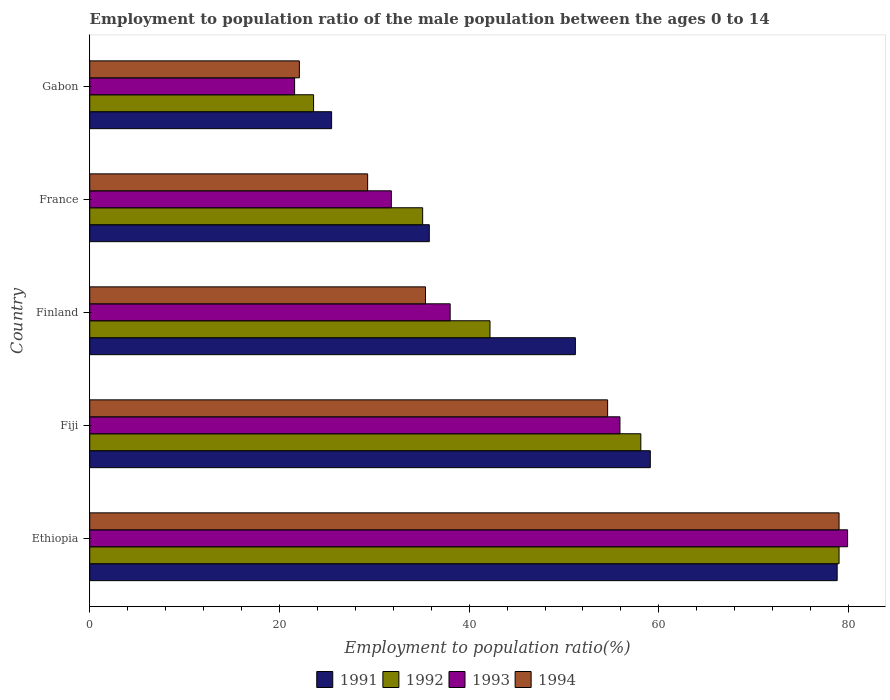How many different coloured bars are there?
Ensure brevity in your answer.  4. How many groups of bars are there?
Provide a succinct answer. 5. Are the number of bars per tick equal to the number of legend labels?
Your answer should be compact. Yes. Are the number of bars on each tick of the Y-axis equal?
Offer a very short reply. Yes. How many bars are there on the 3rd tick from the top?
Offer a very short reply. 4. What is the label of the 2nd group of bars from the top?
Your answer should be compact. France. What is the employment to population ratio in 1994 in France?
Offer a very short reply. 29.3. Across all countries, what is the maximum employment to population ratio in 1992?
Your answer should be compact. 79. In which country was the employment to population ratio in 1992 maximum?
Keep it short and to the point. Ethiopia. In which country was the employment to population ratio in 1991 minimum?
Offer a terse response. Gabon. What is the total employment to population ratio in 1992 in the graph?
Offer a terse response. 238. What is the difference between the employment to population ratio in 1991 in Ethiopia and that in Fiji?
Keep it short and to the point. 19.7. What is the difference between the employment to population ratio in 1993 in France and the employment to population ratio in 1994 in Ethiopia?
Your answer should be very brief. -47.2. What is the average employment to population ratio in 1991 per country?
Make the answer very short. 50.08. What is the difference between the employment to population ratio in 1991 and employment to population ratio in 1992 in Gabon?
Keep it short and to the point. 1.9. In how many countries, is the employment to population ratio in 1992 greater than 64 %?
Make the answer very short. 1. What is the ratio of the employment to population ratio in 1994 in Fiji to that in France?
Give a very brief answer. 1.86. Is the difference between the employment to population ratio in 1991 in Fiji and France greater than the difference between the employment to population ratio in 1992 in Fiji and France?
Keep it short and to the point. Yes. What is the difference between the highest and the second highest employment to population ratio in 1993?
Ensure brevity in your answer.  24. What is the difference between the highest and the lowest employment to population ratio in 1992?
Provide a short and direct response. 55.4. Is the sum of the employment to population ratio in 1994 in Fiji and Finland greater than the maximum employment to population ratio in 1991 across all countries?
Make the answer very short. Yes. Is it the case that in every country, the sum of the employment to population ratio in 1993 and employment to population ratio in 1991 is greater than the sum of employment to population ratio in 1992 and employment to population ratio in 1994?
Offer a very short reply. No. What does the 1st bar from the bottom in France represents?
Make the answer very short. 1991. Is it the case that in every country, the sum of the employment to population ratio in 1994 and employment to population ratio in 1993 is greater than the employment to population ratio in 1992?
Your response must be concise. Yes. How many bars are there?
Keep it short and to the point. 20. How many countries are there in the graph?
Your answer should be very brief. 5. What is the difference between two consecutive major ticks on the X-axis?
Provide a short and direct response. 20. Does the graph contain any zero values?
Provide a short and direct response. No. Where does the legend appear in the graph?
Your answer should be compact. Bottom center. How many legend labels are there?
Give a very brief answer. 4. How are the legend labels stacked?
Make the answer very short. Horizontal. What is the title of the graph?
Offer a terse response. Employment to population ratio of the male population between the ages 0 to 14. Does "1966" appear as one of the legend labels in the graph?
Your response must be concise. No. What is the Employment to population ratio(%) in 1991 in Ethiopia?
Keep it short and to the point. 78.8. What is the Employment to population ratio(%) of 1992 in Ethiopia?
Your answer should be very brief. 79. What is the Employment to population ratio(%) in 1993 in Ethiopia?
Provide a succinct answer. 79.9. What is the Employment to population ratio(%) in 1994 in Ethiopia?
Your answer should be compact. 79. What is the Employment to population ratio(%) in 1991 in Fiji?
Your answer should be compact. 59.1. What is the Employment to population ratio(%) of 1992 in Fiji?
Keep it short and to the point. 58.1. What is the Employment to population ratio(%) in 1993 in Fiji?
Make the answer very short. 55.9. What is the Employment to population ratio(%) in 1994 in Fiji?
Provide a short and direct response. 54.6. What is the Employment to population ratio(%) in 1991 in Finland?
Give a very brief answer. 51.2. What is the Employment to population ratio(%) in 1992 in Finland?
Ensure brevity in your answer.  42.2. What is the Employment to population ratio(%) of 1993 in Finland?
Give a very brief answer. 38. What is the Employment to population ratio(%) of 1994 in Finland?
Ensure brevity in your answer.  35.4. What is the Employment to population ratio(%) in 1991 in France?
Keep it short and to the point. 35.8. What is the Employment to population ratio(%) of 1992 in France?
Your answer should be very brief. 35.1. What is the Employment to population ratio(%) in 1993 in France?
Give a very brief answer. 31.8. What is the Employment to population ratio(%) of 1994 in France?
Your answer should be compact. 29.3. What is the Employment to population ratio(%) in 1992 in Gabon?
Keep it short and to the point. 23.6. What is the Employment to population ratio(%) in 1993 in Gabon?
Offer a very short reply. 21.6. What is the Employment to population ratio(%) in 1994 in Gabon?
Your response must be concise. 22.1. Across all countries, what is the maximum Employment to population ratio(%) of 1991?
Provide a short and direct response. 78.8. Across all countries, what is the maximum Employment to population ratio(%) in 1992?
Provide a succinct answer. 79. Across all countries, what is the maximum Employment to population ratio(%) of 1993?
Offer a terse response. 79.9. Across all countries, what is the maximum Employment to population ratio(%) in 1994?
Provide a succinct answer. 79. Across all countries, what is the minimum Employment to population ratio(%) of 1991?
Your answer should be very brief. 25.5. Across all countries, what is the minimum Employment to population ratio(%) of 1992?
Make the answer very short. 23.6. Across all countries, what is the minimum Employment to population ratio(%) in 1993?
Your answer should be compact. 21.6. Across all countries, what is the minimum Employment to population ratio(%) of 1994?
Provide a short and direct response. 22.1. What is the total Employment to population ratio(%) in 1991 in the graph?
Offer a very short reply. 250.4. What is the total Employment to population ratio(%) of 1992 in the graph?
Provide a short and direct response. 238. What is the total Employment to population ratio(%) in 1993 in the graph?
Provide a succinct answer. 227.2. What is the total Employment to population ratio(%) in 1994 in the graph?
Give a very brief answer. 220.4. What is the difference between the Employment to population ratio(%) in 1991 in Ethiopia and that in Fiji?
Make the answer very short. 19.7. What is the difference between the Employment to population ratio(%) in 1992 in Ethiopia and that in Fiji?
Make the answer very short. 20.9. What is the difference between the Employment to population ratio(%) of 1993 in Ethiopia and that in Fiji?
Make the answer very short. 24. What is the difference between the Employment to population ratio(%) in 1994 in Ethiopia and that in Fiji?
Offer a very short reply. 24.4. What is the difference between the Employment to population ratio(%) in 1991 in Ethiopia and that in Finland?
Offer a very short reply. 27.6. What is the difference between the Employment to population ratio(%) of 1992 in Ethiopia and that in Finland?
Offer a terse response. 36.8. What is the difference between the Employment to population ratio(%) in 1993 in Ethiopia and that in Finland?
Your response must be concise. 41.9. What is the difference between the Employment to population ratio(%) in 1994 in Ethiopia and that in Finland?
Your answer should be very brief. 43.6. What is the difference between the Employment to population ratio(%) of 1992 in Ethiopia and that in France?
Offer a very short reply. 43.9. What is the difference between the Employment to population ratio(%) in 1993 in Ethiopia and that in France?
Provide a succinct answer. 48.1. What is the difference between the Employment to population ratio(%) in 1994 in Ethiopia and that in France?
Offer a terse response. 49.7. What is the difference between the Employment to population ratio(%) in 1991 in Ethiopia and that in Gabon?
Your response must be concise. 53.3. What is the difference between the Employment to population ratio(%) in 1992 in Ethiopia and that in Gabon?
Offer a very short reply. 55.4. What is the difference between the Employment to population ratio(%) in 1993 in Ethiopia and that in Gabon?
Your response must be concise. 58.3. What is the difference between the Employment to population ratio(%) in 1994 in Ethiopia and that in Gabon?
Give a very brief answer. 56.9. What is the difference between the Employment to population ratio(%) in 1991 in Fiji and that in Finland?
Provide a short and direct response. 7.9. What is the difference between the Employment to population ratio(%) in 1993 in Fiji and that in Finland?
Offer a very short reply. 17.9. What is the difference between the Employment to population ratio(%) in 1991 in Fiji and that in France?
Your answer should be very brief. 23.3. What is the difference between the Employment to population ratio(%) in 1993 in Fiji and that in France?
Your answer should be compact. 24.1. What is the difference between the Employment to population ratio(%) of 1994 in Fiji and that in France?
Keep it short and to the point. 25.3. What is the difference between the Employment to population ratio(%) in 1991 in Fiji and that in Gabon?
Ensure brevity in your answer.  33.6. What is the difference between the Employment to population ratio(%) of 1992 in Fiji and that in Gabon?
Offer a terse response. 34.5. What is the difference between the Employment to population ratio(%) of 1993 in Fiji and that in Gabon?
Your response must be concise. 34.3. What is the difference between the Employment to population ratio(%) in 1994 in Fiji and that in Gabon?
Give a very brief answer. 32.5. What is the difference between the Employment to population ratio(%) in 1991 in Finland and that in France?
Your answer should be very brief. 15.4. What is the difference between the Employment to population ratio(%) in 1993 in Finland and that in France?
Your response must be concise. 6.2. What is the difference between the Employment to population ratio(%) in 1994 in Finland and that in France?
Provide a succinct answer. 6.1. What is the difference between the Employment to population ratio(%) of 1991 in Finland and that in Gabon?
Keep it short and to the point. 25.7. What is the difference between the Employment to population ratio(%) of 1993 in Finland and that in Gabon?
Your answer should be compact. 16.4. What is the difference between the Employment to population ratio(%) of 1994 in Finland and that in Gabon?
Give a very brief answer. 13.3. What is the difference between the Employment to population ratio(%) in 1992 in France and that in Gabon?
Your answer should be compact. 11.5. What is the difference between the Employment to population ratio(%) of 1993 in France and that in Gabon?
Offer a very short reply. 10.2. What is the difference between the Employment to population ratio(%) of 1994 in France and that in Gabon?
Your response must be concise. 7.2. What is the difference between the Employment to population ratio(%) in 1991 in Ethiopia and the Employment to population ratio(%) in 1992 in Fiji?
Offer a very short reply. 20.7. What is the difference between the Employment to population ratio(%) in 1991 in Ethiopia and the Employment to population ratio(%) in 1993 in Fiji?
Ensure brevity in your answer.  22.9. What is the difference between the Employment to population ratio(%) of 1991 in Ethiopia and the Employment to population ratio(%) of 1994 in Fiji?
Your answer should be very brief. 24.2. What is the difference between the Employment to population ratio(%) in 1992 in Ethiopia and the Employment to population ratio(%) in 1993 in Fiji?
Provide a short and direct response. 23.1. What is the difference between the Employment to population ratio(%) of 1992 in Ethiopia and the Employment to population ratio(%) of 1994 in Fiji?
Offer a terse response. 24.4. What is the difference between the Employment to population ratio(%) in 1993 in Ethiopia and the Employment to population ratio(%) in 1994 in Fiji?
Ensure brevity in your answer.  25.3. What is the difference between the Employment to population ratio(%) in 1991 in Ethiopia and the Employment to population ratio(%) in 1992 in Finland?
Give a very brief answer. 36.6. What is the difference between the Employment to population ratio(%) of 1991 in Ethiopia and the Employment to population ratio(%) of 1993 in Finland?
Offer a very short reply. 40.8. What is the difference between the Employment to population ratio(%) of 1991 in Ethiopia and the Employment to population ratio(%) of 1994 in Finland?
Give a very brief answer. 43.4. What is the difference between the Employment to population ratio(%) in 1992 in Ethiopia and the Employment to population ratio(%) in 1993 in Finland?
Offer a terse response. 41. What is the difference between the Employment to population ratio(%) in 1992 in Ethiopia and the Employment to population ratio(%) in 1994 in Finland?
Give a very brief answer. 43.6. What is the difference between the Employment to population ratio(%) in 1993 in Ethiopia and the Employment to population ratio(%) in 1994 in Finland?
Your answer should be compact. 44.5. What is the difference between the Employment to population ratio(%) of 1991 in Ethiopia and the Employment to population ratio(%) of 1992 in France?
Your answer should be compact. 43.7. What is the difference between the Employment to population ratio(%) of 1991 in Ethiopia and the Employment to population ratio(%) of 1993 in France?
Your answer should be very brief. 47. What is the difference between the Employment to population ratio(%) of 1991 in Ethiopia and the Employment to population ratio(%) of 1994 in France?
Your response must be concise. 49.5. What is the difference between the Employment to population ratio(%) in 1992 in Ethiopia and the Employment to population ratio(%) in 1993 in France?
Your answer should be very brief. 47.2. What is the difference between the Employment to population ratio(%) in 1992 in Ethiopia and the Employment to population ratio(%) in 1994 in France?
Provide a succinct answer. 49.7. What is the difference between the Employment to population ratio(%) of 1993 in Ethiopia and the Employment to population ratio(%) of 1994 in France?
Make the answer very short. 50.6. What is the difference between the Employment to population ratio(%) of 1991 in Ethiopia and the Employment to population ratio(%) of 1992 in Gabon?
Your answer should be very brief. 55.2. What is the difference between the Employment to population ratio(%) of 1991 in Ethiopia and the Employment to population ratio(%) of 1993 in Gabon?
Your answer should be compact. 57.2. What is the difference between the Employment to population ratio(%) in 1991 in Ethiopia and the Employment to population ratio(%) in 1994 in Gabon?
Ensure brevity in your answer.  56.7. What is the difference between the Employment to population ratio(%) of 1992 in Ethiopia and the Employment to population ratio(%) of 1993 in Gabon?
Keep it short and to the point. 57.4. What is the difference between the Employment to population ratio(%) in 1992 in Ethiopia and the Employment to population ratio(%) in 1994 in Gabon?
Ensure brevity in your answer.  56.9. What is the difference between the Employment to population ratio(%) in 1993 in Ethiopia and the Employment to population ratio(%) in 1994 in Gabon?
Give a very brief answer. 57.8. What is the difference between the Employment to population ratio(%) in 1991 in Fiji and the Employment to population ratio(%) in 1992 in Finland?
Offer a terse response. 16.9. What is the difference between the Employment to population ratio(%) in 1991 in Fiji and the Employment to population ratio(%) in 1993 in Finland?
Give a very brief answer. 21.1. What is the difference between the Employment to population ratio(%) in 1991 in Fiji and the Employment to population ratio(%) in 1994 in Finland?
Give a very brief answer. 23.7. What is the difference between the Employment to population ratio(%) in 1992 in Fiji and the Employment to population ratio(%) in 1993 in Finland?
Provide a succinct answer. 20.1. What is the difference between the Employment to population ratio(%) in 1992 in Fiji and the Employment to population ratio(%) in 1994 in Finland?
Offer a very short reply. 22.7. What is the difference between the Employment to population ratio(%) in 1991 in Fiji and the Employment to population ratio(%) in 1992 in France?
Give a very brief answer. 24. What is the difference between the Employment to population ratio(%) in 1991 in Fiji and the Employment to population ratio(%) in 1993 in France?
Ensure brevity in your answer.  27.3. What is the difference between the Employment to population ratio(%) of 1991 in Fiji and the Employment to population ratio(%) of 1994 in France?
Provide a succinct answer. 29.8. What is the difference between the Employment to population ratio(%) in 1992 in Fiji and the Employment to population ratio(%) in 1993 in France?
Offer a terse response. 26.3. What is the difference between the Employment to population ratio(%) of 1992 in Fiji and the Employment to population ratio(%) of 1994 in France?
Provide a short and direct response. 28.8. What is the difference between the Employment to population ratio(%) in 1993 in Fiji and the Employment to population ratio(%) in 1994 in France?
Make the answer very short. 26.6. What is the difference between the Employment to population ratio(%) of 1991 in Fiji and the Employment to population ratio(%) of 1992 in Gabon?
Your response must be concise. 35.5. What is the difference between the Employment to population ratio(%) in 1991 in Fiji and the Employment to population ratio(%) in 1993 in Gabon?
Ensure brevity in your answer.  37.5. What is the difference between the Employment to population ratio(%) in 1991 in Fiji and the Employment to population ratio(%) in 1994 in Gabon?
Your answer should be compact. 37. What is the difference between the Employment to population ratio(%) of 1992 in Fiji and the Employment to population ratio(%) of 1993 in Gabon?
Offer a terse response. 36.5. What is the difference between the Employment to population ratio(%) in 1993 in Fiji and the Employment to population ratio(%) in 1994 in Gabon?
Provide a succinct answer. 33.8. What is the difference between the Employment to population ratio(%) in 1991 in Finland and the Employment to population ratio(%) in 1994 in France?
Ensure brevity in your answer.  21.9. What is the difference between the Employment to population ratio(%) in 1992 in Finland and the Employment to population ratio(%) in 1994 in France?
Your answer should be compact. 12.9. What is the difference between the Employment to population ratio(%) of 1993 in Finland and the Employment to population ratio(%) of 1994 in France?
Keep it short and to the point. 8.7. What is the difference between the Employment to population ratio(%) in 1991 in Finland and the Employment to population ratio(%) in 1992 in Gabon?
Make the answer very short. 27.6. What is the difference between the Employment to population ratio(%) in 1991 in Finland and the Employment to population ratio(%) in 1993 in Gabon?
Provide a succinct answer. 29.6. What is the difference between the Employment to population ratio(%) in 1991 in Finland and the Employment to population ratio(%) in 1994 in Gabon?
Make the answer very short. 29.1. What is the difference between the Employment to population ratio(%) in 1992 in Finland and the Employment to population ratio(%) in 1993 in Gabon?
Provide a short and direct response. 20.6. What is the difference between the Employment to population ratio(%) of 1992 in Finland and the Employment to population ratio(%) of 1994 in Gabon?
Ensure brevity in your answer.  20.1. What is the difference between the Employment to population ratio(%) in 1993 in Finland and the Employment to population ratio(%) in 1994 in Gabon?
Provide a succinct answer. 15.9. What is the difference between the Employment to population ratio(%) in 1991 in France and the Employment to population ratio(%) in 1992 in Gabon?
Ensure brevity in your answer.  12.2. What is the difference between the Employment to population ratio(%) of 1991 in France and the Employment to population ratio(%) of 1994 in Gabon?
Provide a short and direct response. 13.7. What is the difference between the Employment to population ratio(%) in 1992 in France and the Employment to population ratio(%) in 1993 in Gabon?
Your answer should be very brief. 13.5. What is the average Employment to population ratio(%) in 1991 per country?
Your response must be concise. 50.08. What is the average Employment to population ratio(%) of 1992 per country?
Your answer should be very brief. 47.6. What is the average Employment to population ratio(%) in 1993 per country?
Give a very brief answer. 45.44. What is the average Employment to population ratio(%) in 1994 per country?
Keep it short and to the point. 44.08. What is the difference between the Employment to population ratio(%) of 1992 and Employment to population ratio(%) of 1993 in Ethiopia?
Keep it short and to the point. -0.9. What is the difference between the Employment to population ratio(%) in 1992 and Employment to population ratio(%) in 1994 in Ethiopia?
Your answer should be compact. 0. What is the difference between the Employment to population ratio(%) in 1991 and Employment to population ratio(%) in 1994 in Fiji?
Offer a very short reply. 4.5. What is the difference between the Employment to population ratio(%) of 1992 and Employment to population ratio(%) of 1993 in Fiji?
Provide a short and direct response. 2.2. What is the difference between the Employment to population ratio(%) in 1992 and Employment to population ratio(%) in 1994 in Fiji?
Make the answer very short. 3.5. What is the difference between the Employment to population ratio(%) of 1991 and Employment to population ratio(%) of 1992 in Finland?
Provide a succinct answer. 9. What is the difference between the Employment to population ratio(%) of 1991 and Employment to population ratio(%) of 1994 in Finland?
Provide a short and direct response. 15.8. What is the difference between the Employment to population ratio(%) in 1992 and Employment to population ratio(%) in 1993 in Finland?
Offer a terse response. 4.2. What is the difference between the Employment to population ratio(%) in 1991 and Employment to population ratio(%) in 1992 in France?
Make the answer very short. 0.7. What is the difference between the Employment to population ratio(%) in 1991 and Employment to population ratio(%) in 1993 in France?
Your answer should be very brief. 4. What is the difference between the Employment to population ratio(%) of 1991 and Employment to population ratio(%) of 1994 in France?
Offer a very short reply. 6.5. What is the difference between the Employment to population ratio(%) in 1991 and Employment to population ratio(%) in 1993 in Gabon?
Provide a succinct answer. 3.9. What is the difference between the Employment to population ratio(%) in 1991 and Employment to population ratio(%) in 1994 in Gabon?
Offer a terse response. 3.4. What is the difference between the Employment to population ratio(%) of 1992 and Employment to population ratio(%) of 1993 in Gabon?
Offer a terse response. 2. What is the difference between the Employment to population ratio(%) in 1992 and Employment to population ratio(%) in 1994 in Gabon?
Provide a short and direct response. 1.5. What is the ratio of the Employment to population ratio(%) of 1991 in Ethiopia to that in Fiji?
Offer a very short reply. 1.33. What is the ratio of the Employment to population ratio(%) in 1992 in Ethiopia to that in Fiji?
Ensure brevity in your answer.  1.36. What is the ratio of the Employment to population ratio(%) of 1993 in Ethiopia to that in Fiji?
Your answer should be very brief. 1.43. What is the ratio of the Employment to population ratio(%) of 1994 in Ethiopia to that in Fiji?
Your answer should be very brief. 1.45. What is the ratio of the Employment to population ratio(%) in 1991 in Ethiopia to that in Finland?
Ensure brevity in your answer.  1.54. What is the ratio of the Employment to population ratio(%) in 1992 in Ethiopia to that in Finland?
Offer a terse response. 1.87. What is the ratio of the Employment to population ratio(%) of 1993 in Ethiopia to that in Finland?
Your answer should be compact. 2.1. What is the ratio of the Employment to population ratio(%) of 1994 in Ethiopia to that in Finland?
Offer a very short reply. 2.23. What is the ratio of the Employment to population ratio(%) in 1991 in Ethiopia to that in France?
Keep it short and to the point. 2.2. What is the ratio of the Employment to population ratio(%) in 1992 in Ethiopia to that in France?
Offer a very short reply. 2.25. What is the ratio of the Employment to population ratio(%) of 1993 in Ethiopia to that in France?
Your response must be concise. 2.51. What is the ratio of the Employment to population ratio(%) of 1994 in Ethiopia to that in France?
Provide a short and direct response. 2.7. What is the ratio of the Employment to population ratio(%) in 1991 in Ethiopia to that in Gabon?
Your answer should be compact. 3.09. What is the ratio of the Employment to population ratio(%) in 1992 in Ethiopia to that in Gabon?
Give a very brief answer. 3.35. What is the ratio of the Employment to population ratio(%) in 1993 in Ethiopia to that in Gabon?
Provide a short and direct response. 3.7. What is the ratio of the Employment to population ratio(%) in 1994 in Ethiopia to that in Gabon?
Provide a succinct answer. 3.57. What is the ratio of the Employment to population ratio(%) of 1991 in Fiji to that in Finland?
Give a very brief answer. 1.15. What is the ratio of the Employment to population ratio(%) of 1992 in Fiji to that in Finland?
Keep it short and to the point. 1.38. What is the ratio of the Employment to population ratio(%) in 1993 in Fiji to that in Finland?
Make the answer very short. 1.47. What is the ratio of the Employment to population ratio(%) in 1994 in Fiji to that in Finland?
Provide a succinct answer. 1.54. What is the ratio of the Employment to population ratio(%) in 1991 in Fiji to that in France?
Your answer should be very brief. 1.65. What is the ratio of the Employment to population ratio(%) in 1992 in Fiji to that in France?
Ensure brevity in your answer.  1.66. What is the ratio of the Employment to population ratio(%) of 1993 in Fiji to that in France?
Your response must be concise. 1.76. What is the ratio of the Employment to population ratio(%) in 1994 in Fiji to that in France?
Ensure brevity in your answer.  1.86. What is the ratio of the Employment to population ratio(%) of 1991 in Fiji to that in Gabon?
Your answer should be very brief. 2.32. What is the ratio of the Employment to population ratio(%) of 1992 in Fiji to that in Gabon?
Give a very brief answer. 2.46. What is the ratio of the Employment to population ratio(%) in 1993 in Fiji to that in Gabon?
Provide a succinct answer. 2.59. What is the ratio of the Employment to population ratio(%) in 1994 in Fiji to that in Gabon?
Your answer should be compact. 2.47. What is the ratio of the Employment to population ratio(%) of 1991 in Finland to that in France?
Offer a very short reply. 1.43. What is the ratio of the Employment to population ratio(%) of 1992 in Finland to that in France?
Ensure brevity in your answer.  1.2. What is the ratio of the Employment to population ratio(%) in 1993 in Finland to that in France?
Give a very brief answer. 1.2. What is the ratio of the Employment to population ratio(%) in 1994 in Finland to that in France?
Your response must be concise. 1.21. What is the ratio of the Employment to population ratio(%) in 1991 in Finland to that in Gabon?
Your response must be concise. 2.01. What is the ratio of the Employment to population ratio(%) in 1992 in Finland to that in Gabon?
Make the answer very short. 1.79. What is the ratio of the Employment to population ratio(%) in 1993 in Finland to that in Gabon?
Ensure brevity in your answer.  1.76. What is the ratio of the Employment to population ratio(%) in 1994 in Finland to that in Gabon?
Make the answer very short. 1.6. What is the ratio of the Employment to population ratio(%) in 1991 in France to that in Gabon?
Offer a terse response. 1.4. What is the ratio of the Employment to population ratio(%) in 1992 in France to that in Gabon?
Make the answer very short. 1.49. What is the ratio of the Employment to population ratio(%) in 1993 in France to that in Gabon?
Provide a succinct answer. 1.47. What is the ratio of the Employment to population ratio(%) in 1994 in France to that in Gabon?
Your answer should be very brief. 1.33. What is the difference between the highest and the second highest Employment to population ratio(%) of 1991?
Provide a short and direct response. 19.7. What is the difference between the highest and the second highest Employment to population ratio(%) of 1992?
Make the answer very short. 20.9. What is the difference between the highest and the second highest Employment to population ratio(%) of 1993?
Ensure brevity in your answer.  24. What is the difference between the highest and the second highest Employment to population ratio(%) of 1994?
Give a very brief answer. 24.4. What is the difference between the highest and the lowest Employment to population ratio(%) in 1991?
Ensure brevity in your answer.  53.3. What is the difference between the highest and the lowest Employment to population ratio(%) of 1992?
Keep it short and to the point. 55.4. What is the difference between the highest and the lowest Employment to population ratio(%) in 1993?
Your answer should be compact. 58.3. What is the difference between the highest and the lowest Employment to population ratio(%) of 1994?
Offer a terse response. 56.9. 